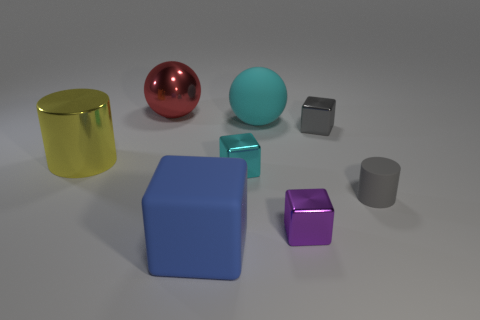Add 1 cubes. How many objects exist? 9 Subtract all spheres. How many objects are left? 6 Add 1 large green matte cylinders. How many large green matte cylinders exist? 1 Subtract 0 brown cylinders. How many objects are left? 8 Subtract all gray blocks. Subtract all large green things. How many objects are left? 7 Add 4 cyan rubber objects. How many cyan rubber objects are left? 5 